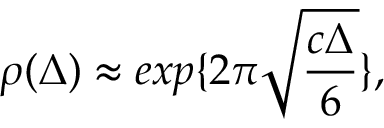<formula> <loc_0><loc_0><loc_500><loc_500>\rho ( \Delta ) \approx e x p \{ 2 \pi \sqrt { \frac { c \Delta } { 6 } } \} ,</formula> 